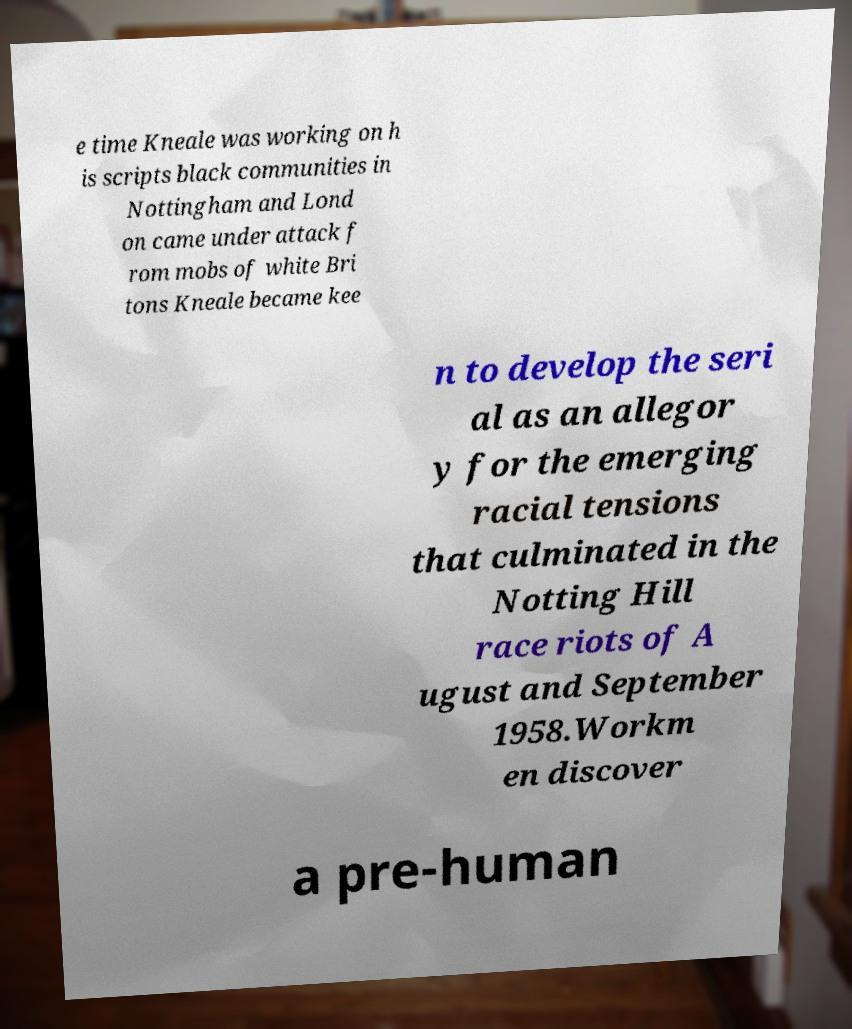Could you assist in decoding the text presented in this image and type it out clearly? e time Kneale was working on h is scripts black communities in Nottingham and Lond on came under attack f rom mobs of white Bri tons Kneale became kee n to develop the seri al as an allegor y for the emerging racial tensions that culminated in the Notting Hill race riots of A ugust and September 1958.Workm en discover a pre-human 